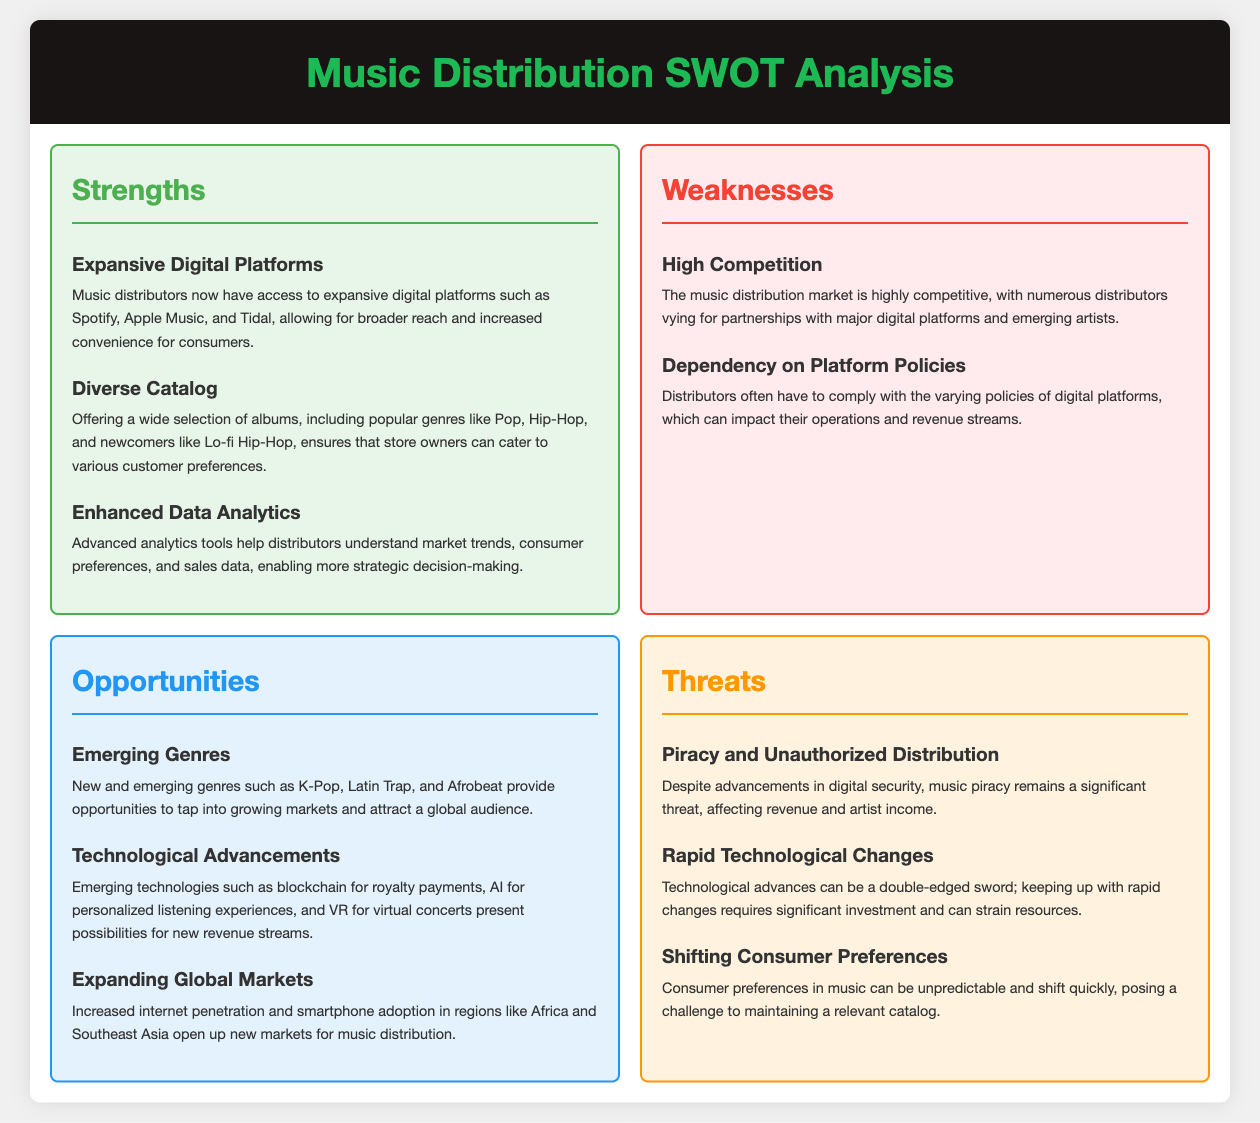What is one emerging genre mentioned? The document lists emerging genres such as K-Pop, Latin Trap, and Afrobeat.
Answer: K-Pop What is a strength of music distributors? The document states that music distributors have access to expansive digital platforms for broader reach.
Answer: Expansive Digital Platforms What is a weakness related to competition? The weakness is related to numerous distributors vying for partnerships with major platforms.
Answer: High Competition What opportunity involves technological advancements? The document mentions blockchain for royalty payments, AI for personalized experiences, and VR for concerts.
Answer: Technological Advancements What threat is posed by piracy? The document highlights that music piracy affects revenue and artist income.
Answer: Piracy and Unauthorized Distribution How many opportunities are listed in the document? There are three opportunities described: Emerging Genres, Technological Advancements, and Expanding Global Markets.
Answer: Three What is a specific consumer preference threat? Shifting consumer preferences in music can lead to challenges in maintaining a relevant catalog.
Answer: Shifting Consumer Preferences What are the two sections of the SWOT analysis? The two sections highlighted are Opportunities and Threats.
Answer: Opportunities and Threats What does enhanced data analytics help with? It helps distributors understand market trends, consumer preferences, and sales data.
Answer: Market trends, consumer preferences, and sales data 